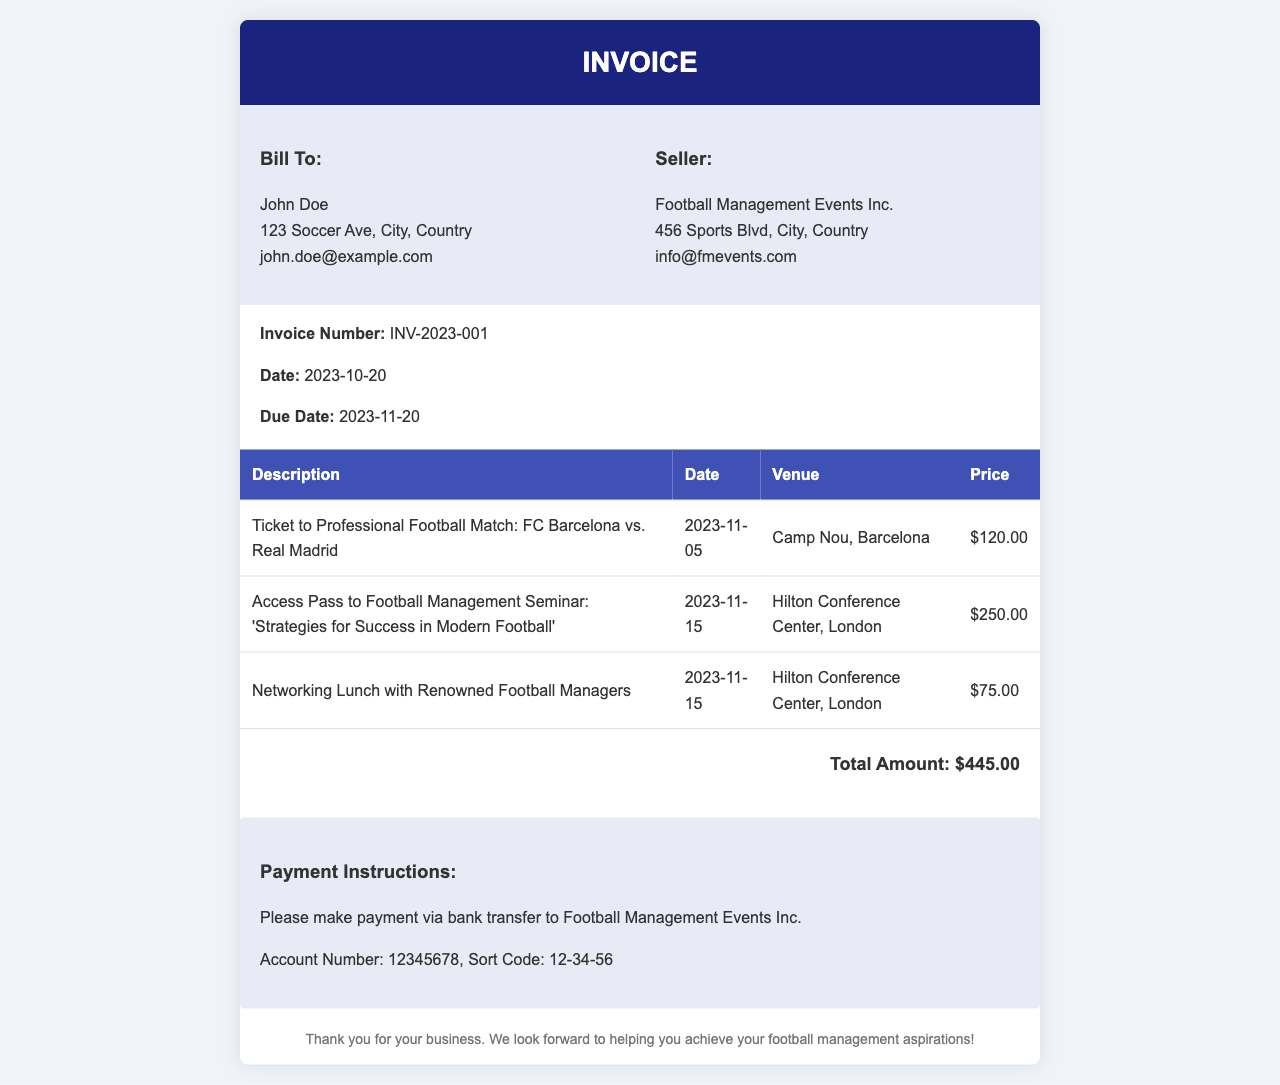what is the invoice number? The invoice number is specified under "Invoice Number" and is unique to this document.
Answer: INV-2023-001 what is the total amount due? The total amount is calculated at the bottom of the invoice, summarizing the total costs without taxes or fees.
Answer: $445.00 when is the due date? The due date is indicated clearly in the document under "Due Date."
Answer: 2023-11-20 who is the seller? The seller is mentioned in the "Seller" section and is the organization providing the invoice.
Answer: Football Management Events Inc how many tickets are listed in the invoice? The invoice contains multiple line items; counting them gives us a total for tickets and services.
Answer: 3 what is the date of the football match? The date of the professional football match can be found under the specific event in the invoice.
Answer: 2023-11-05 what venue will host the football management seminar? The venue for the seminar is provided in the description of that particular service in the invoice.
Answer: Hilton Conference Center, London what type of event is the networking lunch associated with? The networking lunch is related to meeting professionals, which is indicated in its description on the invoice.
Answer: Networking with Renowned Football Managers who is the billed party? The billed party or customer is specified in the "Bill To" section of the document.
Answer: John Doe 